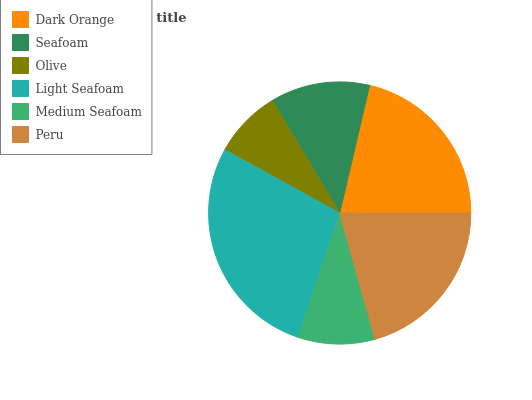Is Olive the minimum?
Answer yes or no. Yes. Is Light Seafoam the maximum?
Answer yes or no. Yes. Is Seafoam the minimum?
Answer yes or no. No. Is Seafoam the maximum?
Answer yes or no. No. Is Dark Orange greater than Seafoam?
Answer yes or no. Yes. Is Seafoam less than Dark Orange?
Answer yes or no. Yes. Is Seafoam greater than Dark Orange?
Answer yes or no. No. Is Dark Orange less than Seafoam?
Answer yes or no. No. Is Peru the high median?
Answer yes or no. Yes. Is Seafoam the low median?
Answer yes or no. Yes. Is Olive the high median?
Answer yes or no. No. Is Light Seafoam the low median?
Answer yes or no. No. 